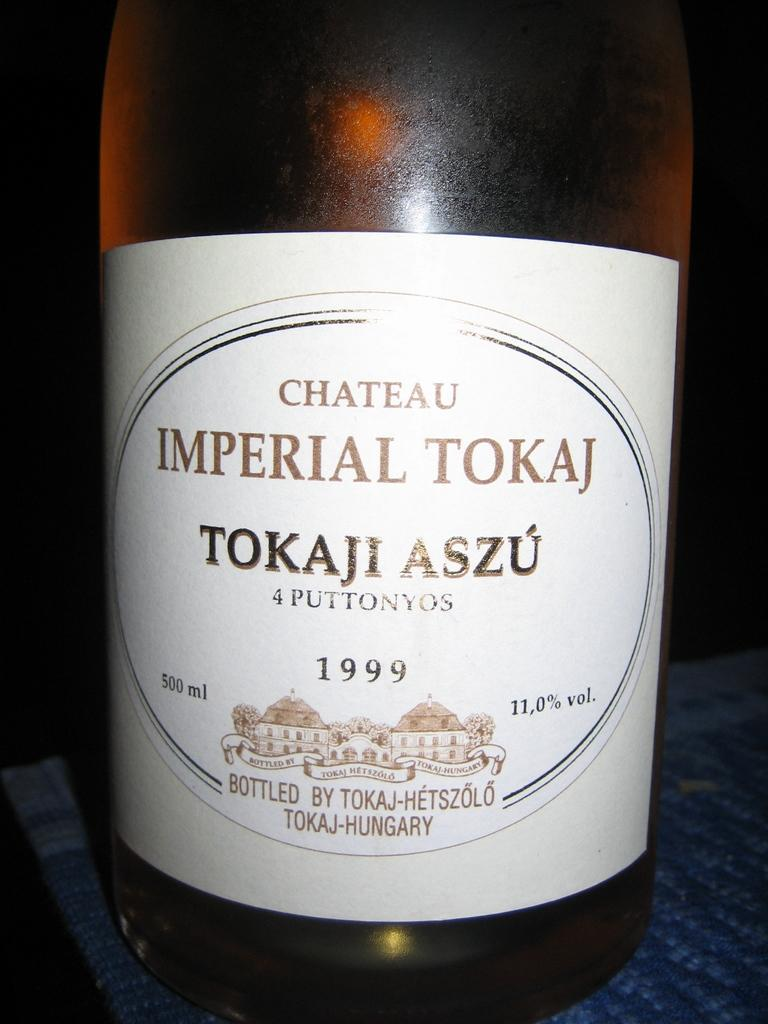<image>
Summarize the visual content of the image. Bottle with a white label that has the year 1999 on it. 